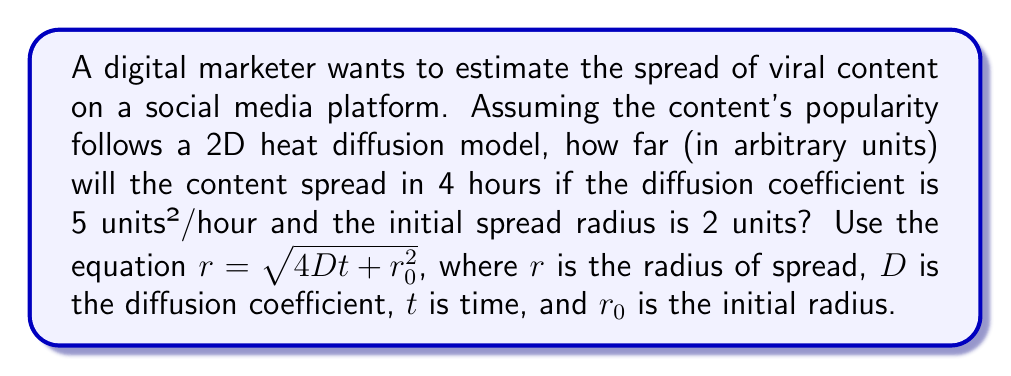Show me your answer to this math problem. Let's approach this step-by-step:

1) We are given the following information:
   - Diffusion coefficient, $D = 5$ units²/hour
   - Time, $t = 4$ hours
   - Initial radius, $r_0 = 2$ units

2) We need to use the equation: $r = \sqrt{4Dt + r_0^2}$

3) Let's substitute the values:
   $r = \sqrt{4 \cdot 5 \cdot 4 + 2^2}$

4) Simplify inside the parentheses:
   $r = \sqrt{80 + 4}$

5) Add under the square root:
   $r = \sqrt{84}$

6) Simplify the square root:
   $r = 2\sqrt{21}$

Therefore, after 4 hours, the content will have spread to a radius of $2\sqrt{21}$ units.
Answer: $2\sqrt{21}$ units 